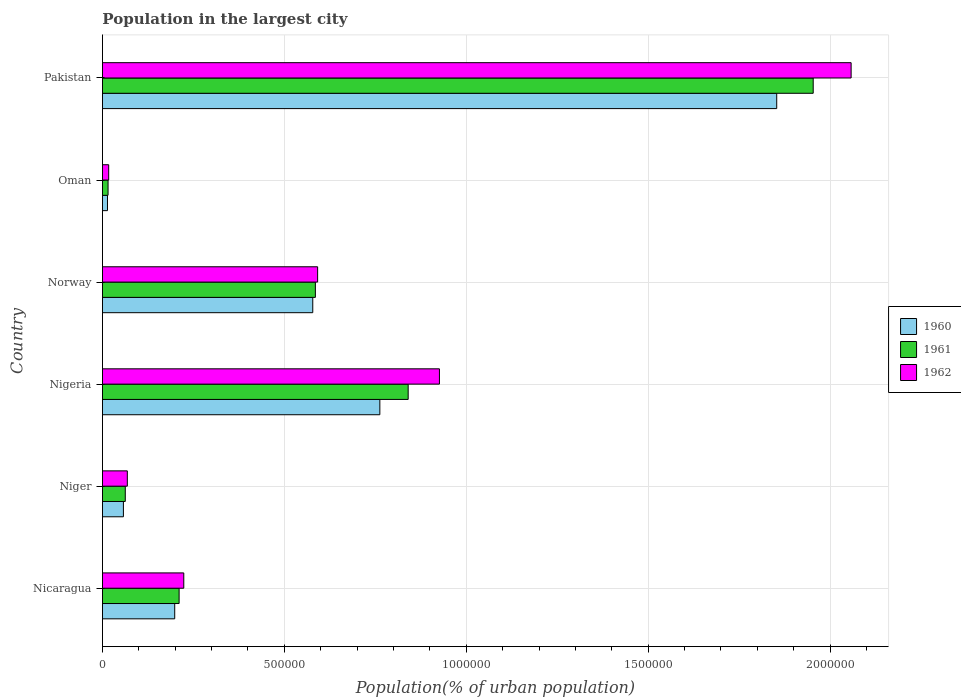How many different coloured bars are there?
Your answer should be compact. 3. Are the number of bars on each tick of the Y-axis equal?
Offer a very short reply. Yes. How many bars are there on the 1st tick from the top?
Make the answer very short. 3. What is the label of the 6th group of bars from the top?
Provide a short and direct response. Nicaragua. In how many cases, is the number of bars for a given country not equal to the number of legend labels?
Your answer should be very brief. 0. What is the population in the largest city in 1962 in Nicaragua?
Provide a succinct answer. 2.24e+05. Across all countries, what is the maximum population in the largest city in 1960?
Your answer should be very brief. 1.85e+06. Across all countries, what is the minimum population in the largest city in 1960?
Offer a very short reply. 1.38e+04. In which country was the population in the largest city in 1962 maximum?
Make the answer very short. Pakistan. In which country was the population in the largest city in 1960 minimum?
Make the answer very short. Oman. What is the total population in the largest city in 1960 in the graph?
Your answer should be compact. 3.46e+06. What is the difference between the population in the largest city in 1962 in Nigeria and that in Oman?
Provide a short and direct response. 9.09e+05. What is the difference between the population in the largest city in 1962 in Norway and the population in the largest city in 1960 in Nigeria?
Your answer should be very brief. -1.71e+05. What is the average population in the largest city in 1960 per country?
Give a very brief answer. 5.77e+05. What is the difference between the population in the largest city in 1960 and population in the largest city in 1962 in Oman?
Give a very brief answer. -3326. What is the ratio of the population in the largest city in 1961 in Niger to that in Pakistan?
Give a very brief answer. 0.03. What is the difference between the highest and the second highest population in the largest city in 1960?
Make the answer very short. 1.09e+06. What is the difference between the highest and the lowest population in the largest city in 1960?
Give a very brief answer. 1.84e+06. What does the 1st bar from the top in Oman represents?
Provide a short and direct response. 1962. How many bars are there?
Offer a terse response. 18. Are all the bars in the graph horizontal?
Provide a short and direct response. Yes. How many countries are there in the graph?
Offer a very short reply. 6. What is the difference between two consecutive major ticks on the X-axis?
Offer a very short reply. 5.00e+05. Does the graph contain any zero values?
Offer a terse response. No. Where does the legend appear in the graph?
Ensure brevity in your answer.  Center right. How many legend labels are there?
Provide a succinct answer. 3. How are the legend labels stacked?
Offer a very short reply. Vertical. What is the title of the graph?
Your answer should be compact. Population in the largest city. Does "1994" appear as one of the legend labels in the graph?
Provide a succinct answer. No. What is the label or title of the X-axis?
Give a very brief answer. Population(% of urban population). What is the Population(% of urban population) in 1960 in Nicaragua?
Your response must be concise. 1.99e+05. What is the Population(% of urban population) in 1961 in Nicaragua?
Keep it short and to the point. 2.11e+05. What is the Population(% of urban population) of 1962 in Nicaragua?
Your response must be concise. 2.24e+05. What is the Population(% of urban population) of 1960 in Niger?
Your answer should be compact. 5.75e+04. What is the Population(% of urban population) of 1961 in Niger?
Your response must be concise. 6.27e+04. What is the Population(% of urban population) in 1962 in Niger?
Offer a very short reply. 6.83e+04. What is the Population(% of urban population) of 1960 in Nigeria?
Keep it short and to the point. 7.62e+05. What is the Population(% of urban population) of 1961 in Nigeria?
Offer a very short reply. 8.40e+05. What is the Population(% of urban population) of 1962 in Nigeria?
Provide a succinct answer. 9.26e+05. What is the Population(% of urban population) in 1960 in Norway?
Provide a short and direct response. 5.78e+05. What is the Population(% of urban population) in 1961 in Norway?
Provide a short and direct response. 5.85e+05. What is the Population(% of urban population) of 1962 in Norway?
Make the answer very short. 5.91e+05. What is the Population(% of urban population) of 1960 in Oman?
Ensure brevity in your answer.  1.38e+04. What is the Population(% of urban population) in 1961 in Oman?
Provide a succinct answer. 1.54e+04. What is the Population(% of urban population) of 1962 in Oman?
Give a very brief answer. 1.71e+04. What is the Population(% of urban population) in 1960 in Pakistan?
Make the answer very short. 1.85e+06. What is the Population(% of urban population) of 1961 in Pakistan?
Offer a very short reply. 1.95e+06. What is the Population(% of urban population) in 1962 in Pakistan?
Keep it short and to the point. 2.06e+06. Across all countries, what is the maximum Population(% of urban population) of 1960?
Offer a very short reply. 1.85e+06. Across all countries, what is the maximum Population(% of urban population) of 1961?
Offer a very short reply. 1.95e+06. Across all countries, what is the maximum Population(% of urban population) of 1962?
Offer a very short reply. 2.06e+06. Across all countries, what is the minimum Population(% of urban population) in 1960?
Your answer should be compact. 1.38e+04. Across all countries, what is the minimum Population(% of urban population) of 1961?
Ensure brevity in your answer.  1.54e+04. Across all countries, what is the minimum Population(% of urban population) of 1962?
Provide a succinct answer. 1.71e+04. What is the total Population(% of urban population) in 1960 in the graph?
Offer a terse response. 3.46e+06. What is the total Population(% of urban population) of 1961 in the graph?
Your response must be concise. 3.67e+06. What is the total Population(% of urban population) of 1962 in the graph?
Make the answer very short. 3.88e+06. What is the difference between the Population(% of urban population) of 1960 in Nicaragua and that in Niger?
Ensure brevity in your answer.  1.41e+05. What is the difference between the Population(% of urban population) of 1961 in Nicaragua and that in Niger?
Keep it short and to the point. 1.48e+05. What is the difference between the Population(% of urban population) in 1962 in Nicaragua and that in Niger?
Keep it short and to the point. 1.55e+05. What is the difference between the Population(% of urban population) of 1960 in Nicaragua and that in Nigeria?
Make the answer very short. -5.64e+05. What is the difference between the Population(% of urban population) in 1961 in Nicaragua and that in Nigeria?
Give a very brief answer. -6.30e+05. What is the difference between the Population(% of urban population) in 1962 in Nicaragua and that in Nigeria?
Provide a succinct answer. -7.03e+05. What is the difference between the Population(% of urban population) in 1960 in Nicaragua and that in Norway?
Keep it short and to the point. -3.79e+05. What is the difference between the Population(% of urban population) in 1961 in Nicaragua and that in Norway?
Provide a succinct answer. -3.75e+05. What is the difference between the Population(% of urban population) of 1962 in Nicaragua and that in Norway?
Ensure brevity in your answer.  -3.68e+05. What is the difference between the Population(% of urban population) in 1960 in Nicaragua and that in Oman?
Make the answer very short. 1.85e+05. What is the difference between the Population(% of urban population) of 1961 in Nicaragua and that in Oman?
Offer a very short reply. 1.95e+05. What is the difference between the Population(% of urban population) of 1962 in Nicaragua and that in Oman?
Ensure brevity in your answer.  2.06e+05. What is the difference between the Population(% of urban population) of 1960 in Nicaragua and that in Pakistan?
Offer a very short reply. -1.65e+06. What is the difference between the Population(% of urban population) in 1961 in Nicaragua and that in Pakistan?
Ensure brevity in your answer.  -1.74e+06. What is the difference between the Population(% of urban population) in 1962 in Nicaragua and that in Pakistan?
Ensure brevity in your answer.  -1.83e+06. What is the difference between the Population(% of urban population) in 1960 in Niger and that in Nigeria?
Ensure brevity in your answer.  -7.05e+05. What is the difference between the Population(% of urban population) in 1961 in Niger and that in Nigeria?
Your response must be concise. -7.78e+05. What is the difference between the Population(% of urban population) of 1962 in Niger and that in Nigeria?
Ensure brevity in your answer.  -8.58e+05. What is the difference between the Population(% of urban population) in 1960 in Niger and that in Norway?
Give a very brief answer. -5.20e+05. What is the difference between the Population(% of urban population) in 1961 in Niger and that in Norway?
Keep it short and to the point. -5.23e+05. What is the difference between the Population(% of urban population) in 1962 in Niger and that in Norway?
Your response must be concise. -5.23e+05. What is the difference between the Population(% of urban population) in 1960 in Niger and that in Oman?
Your response must be concise. 4.38e+04. What is the difference between the Population(% of urban population) of 1961 in Niger and that in Oman?
Give a very brief answer. 4.73e+04. What is the difference between the Population(% of urban population) in 1962 in Niger and that in Oman?
Make the answer very short. 5.12e+04. What is the difference between the Population(% of urban population) of 1960 in Niger and that in Pakistan?
Ensure brevity in your answer.  -1.80e+06. What is the difference between the Population(% of urban population) in 1961 in Niger and that in Pakistan?
Give a very brief answer. -1.89e+06. What is the difference between the Population(% of urban population) in 1962 in Niger and that in Pakistan?
Offer a terse response. -1.99e+06. What is the difference between the Population(% of urban population) of 1960 in Nigeria and that in Norway?
Provide a succinct answer. 1.84e+05. What is the difference between the Population(% of urban population) of 1961 in Nigeria and that in Norway?
Provide a short and direct response. 2.55e+05. What is the difference between the Population(% of urban population) of 1962 in Nigeria and that in Norway?
Keep it short and to the point. 3.35e+05. What is the difference between the Population(% of urban population) in 1960 in Nigeria and that in Oman?
Your answer should be very brief. 7.49e+05. What is the difference between the Population(% of urban population) of 1961 in Nigeria and that in Oman?
Your response must be concise. 8.25e+05. What is the difference between the Population(% of urban population) of 1962 in Nigeria and that in Oman?
Your answer should be very brief. 9.09e+05. What is the difference between the Population(% of urban population) in 1960 in Nigeria and that in Pakistan?
Keep it short and to the point. -1.09e+06. What is the difference between the Population(% of urban population) of 1961 in Nigeria and that in Pakistan?
Ensure brevity in your answer.  -1.11e+06. What is the difference between the Population(% of urban population) of 1962 in Nigeria and that in Pakistan?
Ensure brevity in your answer.  -1.13e+06. What is the difference between the Population(% of urban population) in 1960 in Norway and that in Oman?
Keep it short and to the point. 5.64e+05. What is the difference between the Population(% of urban population) in 1961 in Norway and that in Oman?
Provide a succinct answer. 5.70e+05. What is the difference between the Population(% of urban population) of 1962 in Norway and that in Oman?
Provide a succinct answer. 5.74e+05. What is the difference between the Population(% of urban population) of 1960 in Norway and that in Pakistan?
Ensure brevity in your answer.  -1.28e+06. What is the difference between the Population(% of urban population) of 1961 in Norway and that in Pakistan?
Ensure brevity in your answer.  -1.37e+06. What is the difference between the Population(% of urban population) of 1962 in Norway and that in Pakistan?
Offer a terse response. -1.47e+06. What is the difference between the Population(% of urban population) of 1960 in Oman and that in Pakistan?
Offer a very short reply. -1.84e+06. What is the difference between the Population(% of urban population) of 1961 in Oman and that in Pakistan?
Provide a short and direct response. -1.94e+06. What is the difference between the Population(% of urban population) in 1962 in Oman and that in Pakistan?
Provide a short and direct response. -2.04e+06. What is the difference between the Population(% of urban population) in 1960 in Nicaragua and the Population(% of urban population) in 1961 in Niger?
Keep it short and to the point. 1.36e+05. What is the difference between the Population(% of urban population) in 1960 in Nicaragua and the Population(% of urban population) in 1962 in Niger?
Ensure brevity in your answer.  1.30e+05. What is the difference between the Population(% of urban population) of 1961 in Nicaragua and the Population(% of urban population) of 1962 in Niger?
Offer a very short reply. 1.42e+05. What is the difference between the Population(% of urban population) in 1960 in Nicaragua and the Population(% of urban population) in 1961 in Nigeria?
Keep it short and to the point. -6.42e+05. What is the difference between the Population(% of urban population) of 1960 in Nicaragua and the Population(% of urban population) of 1962 in Nigeria?
Your answer should be very brief. -7.28e+05. What is the difference between the Population(% of urban population) of 1961 in Nicaragua and the Population(% of urban population) of 1962 in Nigeria?
Provide a short and direct response. -7.16e+05. What is the difference between the Population(% of urban population) in 1960 in Nicaragua and the Population(% of urban population) in 1961 in Norway?
Offer a very short reply. -3.87e+05. What is the difference between the Population(% of urban population) in 1960 in Nicaragua and the Population(% of urban population) in 1962 in Norway?
Offer a terse response. -3.93e+05. What is the difference between the Population(% of urban population) in 1961 in Nicaragua and the Population(% of urban population) in 1962 in Norway?
Offer a terse response. -3.81e+05. What is the difference between the Population(% of urban population) in 1960 in Nicaragua and the Population(% of urban population) in 1961 in Oman?
Make the answer very short. 1.83e+05. What is the difference between the Population(% of urban population) of 1960 in Nicaragua and the Population(% of urban population) of 1962 in Oman?
Give a very brief answer. 1.81e+05. What is the difference between the Population(% of urban population) of 1961 in Nicaragua and the Population(% of urban population) of 1962 in Oman?
Provide a succinct answer. 1.94e+05. What is the difference between the Population(% of urban population) of 1960 in Nicaragua and the Population(% of urban population) of 1961 in Pakistan?
Offer a very short reply. -1.76e+06. What is the difference between the Population(% of urban population) of 1960 in Nicaragua and the Population(% of urban population) of 1962 in Pakistan?
Make the answer very short. -1.86e+06. What is the difference between the Population(% of urban population) of 1961 in Nicaragua and the Population(% of urban population) of 1962 in Pakistan?
Make the answer very short. -1.85e+06. What is the difference between the Population(% of urban population) in 1960 in Niger and the Population(% of urban population) in 1961 in Nigeria?
Keep it short and to the point. -7.83e+05. What is the difference between the Population(% of urban population) of 1960 in Niger and the Population(% of urban population) of 1962 in Nigeria?
Give a very brief answer. -8.69e+05. What is the difference between the Population(% of urban population) in 1961 in Niger and the Population(% of urban population) in 1962 in Nigeria?
Offer a very short reply. -8.64e+05. What is the difference between the Population(% of urban population) of 1960 in Niger and the Population(% of urban population) of 1961 in Norway?
Offer a very short reply. -5.28e+05. What is the difference between the Population(% of urban population) in 1960 in Niger and the Population(% of urban population) in 1962 in Norway?
Provide a short and direct response. -5.34e+05. What is the difference between the Population(% of urban population) in 1961 in Niger and the Population(% of urban population) in 1962 in Norway?
Keep it short and to the point. -5.29e+05. What is the difference between the Population(% of urban population) in 1960 in Niger and the Population(% of urban population) in 1961 in Oman?
Give a very brief answer. 4.22e+04. What is the difference between the Population(% of urban population) in 1960 in Niger and the Population(% of urban population) in 1962 in Oman?
Provide a succinct answer. 4.04e+04. What is the difference between the Population(% of urban population) in 1961 in Niger and the Population(% of urban population) in 1962 in Oman?
Offer a terse response. 4.56e+04. What is the difference between the Population(% of urban population) of 1960 in Niger and the Population(% of urban population) of 1961 in Pakistan?
Make the answer very short. -1.90e+06. What is the difference between the Population(% of urban population) in 1960 in Niger and the Population(% of urban population) in 1962 in Pakistan?
Keep it short and to the point. -2.00e+06. What is the difference between the Population(% of urban population) of 1961 in Niger and the Population(% of urban population) of 1962 in Pakistan?
Provide a short and direct response. -2.00e+06. What is the difference between the Population(% of urban population) in 1960 in Nigeria and the Population(% of urban population) in 1961 in Norway?
Give a very brief answer. 1.77e+05. What is the difference between the Population(% of urban population) of 1960 in Nigeria and the Population(% of urban population) of 1962 in Norway?
Your response must be concise. 1.71e+05. What is the difference between the Population(% of urban population) of 1961 in Nigeria and the Population(% of urban population) of 1962 in Norway?
Your response must be concise. 2.49e+05. What is the difference between the Population(% of urban population) of 1960 in Nigeria and the Population(% of urban population) of 1961 in Oman?
Your response must be concise. 7.47e+05. What is the difference between the Population(% of urban population) in 1960 in Nigeria and the Population(% of urban population) in 1962 in Oman?
Ensure brevity in your answer.  7.45e+05. What is the difference between the Population(% of urban population) of 1961 in Nigeria and the Population(% of urban population) of 1962 in Oman?
Offer a very short reply. 8.23e+05. What is the difference between the Population(% of urban population) of 1960 in Nigeria and the Population(% of urban population) of 1961 in Pakistan?
Offer a terse response. -1.19e+06. What is the difference between the Population(% of urban population) of 1960 in Nigeria and the Population(% of urban population) of 1962 in Pakistan?
Provide a short and direct response. -1.30e+06. What is the difference between the Population(% of urban population) in 1961 in Nigeria and the Population(% of urban population) in 1962 in Pakistan?
Keep it short and to the point. -1.22e+06. What is the difference between the Population(% of urban population) of 1960 in Norway and the Population(% of urban population) of 1961 in Oman?
Ensure brevity in your answer.  5.63e+05. What is the difference between the Population(% of urban population) in 1960 in Norway and the Population(% of urban population) in 1962 in Oman?
Offer a very short reply. 5.61e+05. What is the difference between the Population(% of urban population) of 1961 in Norway and the Population(% of urban population) of 1962 in Oman?
Offer a terse response. 5.68e+05. What is the difference between the Population(% of urban population) of 1960 in Norway and the Population(% of urban population) of 1961 in Pakistan?
Your answer should be compact. -1.38e+06. What is the difference between the Population(% of urban population) in 1960 in Norway and the Population(% of urban population) in 1962 in Pakistan?
Provide a short and direct response. -1.48e+06. What is the difference between the Population(% of urban population) in 1961 in Norway and the Population(% of urban population) in 1962 in Pakistan?
Your answer should be compact. -1.47e+06. What is the difference between the Population(% of urban population) of 1960 in Oman and the Population(% of urban population) of 1961 in Pakistan?
Give a very brief answer. -1.94e+06. What is the difference between the Population(% of urban population) of 1960 in Oman and the Population(% of urban population) of 1962 in Pakistan?
Your response must be concise. -2.04e+06. What is the difference between the Population(% of urban population) of 1961 in Oman and the Population(% of urban population) of 1962 in Pakistan?
Make the answer very short. -2.04e+06. What is the average Population(% of urban population) of 1960 per country?
Provide a short and direct response. 5.77e+05. What is the average Population(% of urban population) in 1961 per country?
Offer a very short reply. 6.11e+05. What is the average Population(% of urban population) of 1962 per country?
Your answer should be compact. 6.47e+05. What is the difference between the Population(% of urban population) in 1960 and Population(% of urban population) in 1961 in Nicaragua?
Your answer should be very brief. -1.21e+04. What is the difference between the Population(% of urban population) in 1960 and Population(% of urban population) in 1962 in Nicaragua?
Your response must be concise. -2.49e+04. What is the difference between the Population(% of urban population) of 1961 and Population(% of urban population) of 1962 in Nicaragua?
Your answer should be compact. -1.28e+04. What is the difference between the Population(% of urban population) in 1960 and Population(% of urban population) in 1961 in Niger?
Provide a succinct answer. -5156. What is the difference between the Population(% of urban population) in 1960 and Population(% of urban population) in 1962 in Niger?
Keep it short and to the point. -1.08e+04. What is the difference between the Population(% of urban population) in 1961 and Population(% of urban population) in 1962 in Niger?
Offer a very short reply. -5625. What is the difference between the Population(% of urban population) of 1960 and Population(% of urban population) of 1961 in Nigeria?
Your answer should be compact. -7.79e+04. What is the difference between the Population(% of urban population) of 1960 and Population(% of urban population) of 1962 in Nigeria?
Provide a succinct answer. -1.64e+05. What is the difference between the Population(% of urban population) of 1961 and Population(% of urban population) of 1962 in Nigeria?
Ensure brevity in your answer.  -8.59e+04. What is the difference between the Population(% of urban population) in 1960 and Population(% of urban population) in 1961 in Norway?
Offer a very short reply. -7186. What is the difference between the Population(% of urban population) of 1960 and Population(% of urban population) of 1962 in Norway?
Offer a terse response. -1.34e+04. What is the difference between the Population(% of urban population) in 1961 and Population(% of urban population) in 1962 in Norway?
Make the answer very short. -6168. What is the difference between the Population(% of urban population) in 1960 and Population(% of urban population) in 1961 in Oman?
Give a very brief answer. -1572. What is the difference between the Population(% of urban population) in 1960 and Population(% of urban population) in 1962 in Oman?
Your response must be concise. -3326. What is the difference between the Population(% of urban population) in 1961 and Population(% of urban population) in 1962 in Oman?
Provide a succinct answer. -1754. What is the difference between the Population(% of urban population) of 1960 and Population(% of urban population) of 1961 in Pakistan?
Ensure brevity in your answer.  -1.00e+05. What is the difference between the Population(% of urban population) in 1960 and Population(% of urban population) in 1962 in Pakistan?
Keep it short and to the point. -2.05e+05. What is the difference between the Population(% of urban population) in 1961 and Population(% of urban population) in 1962 in Pakistan?
Provide a short and direct response. -1.04e+05. What is the ratio of the Population(% of urban population) in 1960 in Nicaragua to that in Niger?
Keep it short and to the point. 3.45. What is the ratio of the Population(% of urban population) in 1961 in Nicaragua to that in Niger?
Your answer should be compact. 3.36. What is the ratio of the Population(% of urban population) of 1962 in Nicaragua to that in Niger?
Ensure brevity in your answer.  3.27. What is the ratio of the Population(% of urban population) in 1960 in Nicaragua to that in Nigeria?
Provide a succinct answer. 0.26. What is the ratio of the Population(% of urban population) in 1961 in Nicaragua to that in Nigeria?
Your answer should be very brief. 0.25. What is the ratio of the Population(% of urban population) in 1962 in Nicaragua to that in Nigeria?
Your answer should be very brief. 0.24. What is the ratio of the Population(% of urban population) of 1960 in Nicaragua to that in Norway?
Give a very brief answer. 0.34. What is the ratio of the Population(% of urban population) of 1961 in Nicaragua to that in Norway?
Your answer should be very brief. 0.36. What is the ratio of the Population(% of urban population) of 1962 in Nicaragua to that in Norway?
Offer a terse response. 0.38. What is the ratio of the Population(% of urban population) of 1960 in Nicaragua to that in Oman?
Give a very brief answer. 14.4. What is the ratio of the Population(% of urban population) of 1961 in Nicaragua to that in Oman?
Your answer should be very brief. 13.71. What is the ratio of the Population(% of urban population) of 1962 in Nicaragua to that in Oman?
Your answer should be compact. 13.06. What is the ratio of the Population(% of urban population) of 1960 in Nicaragua to that in Pakistan?
Your response must be concise. 0.11. What is the ratio of the Population(% of urban population) of 1961 in Nicaragua to that in Pakistan?
Your response must be concise. 0.11. What is the ratio of the Population(% of urban population) in 1962 in Nicaragua to that in Pakistan?
Offer a very short reply. 0.11. What is the ratio of the Population(% of urban population) in 1960 in Niger to that in Nigeria?
Provide a succinct answer. 0.08. What is the ratio of the Population(% of urban population) in 1961 in Niger to that in Nigeria?
Your answer should be compact. 0.07. What is the ratio of the Population(% of urban population) of 1962 in Niger to that in Nigeria?
Your response must be concise. 0.07. What is the ratio of the Population(% of urban population) in 1960 in Niger to that in Norway?
Make the answer very short. 0.1. What is the ratio of the Population(% of urban population) of 1961 in Niger to that in Norway?
Ensure brevity in your answer.  0.11. What is the ratio of the Population(% of urban population) of 1962 in Niger to that in Norway?
Your answer should be very brief. 0.12. What is the ratio of the Population(% of urban population) in 1960 in Niger to that in Oman?
Offer a terse response. 4.17. What is the ratio of the Population(% of urban population) of 1961 in Niger to that in Oman?
Your answer should be compact. 4.08. What is the ratio of the Population(% of urban population) of 1962 in Niger to that in Oman?
Offer a very short reply. 3.99. What is the ratio of the Population(% of urban population) of 1960 in Niger to that in Pakistan?
Offer a terse response. 0.03. What is the ratio of the Population(% of urban population) of 1961 in Niger to that in Pakistan?
Ensure brevity in your answer.  0.03. What is the ratio of the Population(% of urban population) of 1962 in Niger to that in Pakistan?
Offer a very short reply. 0.03. What is the ratio of the Population(% of urban population) in 1960 in Nigeria to that in Norway?
Offer a terse response. 1.32. What is the ratio of the Population(% of urban population) in 1961 in Nigeria to that in Norway?
Provide a succinct answer. 1.44. What is the ratio of the Population(% of urban population) in 1962 in Nigeria to that in Norway?
Make the answer very short. 1.57. What is the ratio of the Population(% of urban population) of 1960 in Nigeria to that in Oman?
Your answer should be very brief. 55.28. What is the ratio of the Population(% of urban population) of 1961 in Nigeria to that in Oman?
Give a very brief answer. 54.69. What is the ratio of the Population(% of urban population) in 1962 in Nigeria to that in Oman?
Ensure brevity in your answer.  54.11. What is the ratio of the Population(% of urban population) of 1960 in Nigeria to that in Pakistan?
Offer a very short reply. 0.41. What is the ratio of the Population(% of urban population) in 1961 in Nigeria to that in Pakistan?
Keep it short and to the point. 0.43. What is the ratio of the Population(% of urban population) in 1962 in Nigeria to that in Pakistan?
Offer a terse response. 0.45. What is the ratio of the Population(% of urban population) in 1960 in Norway to that in Oman?
Give a very brief answer. 41.91. What is the ratio of the Population(% of urban population) of 1961 in Norway to that in Oman?
Offer a terse response. 38.09. What is the ratio of the Population(% of urban population) of 1962 in Norway to that in Oman?
Your answer should be very brief. 34.55. What is the ratio of the Population(% of urban population) of 1960 in Norway to that in Pakistan?
Offer a terse response. 0.31. What is the ratio of the Population(% of urban population) of 1961 in Norway to that in Pakistan?
Provide a succinct answer. 0.3. What is the ratio of the Population(% of urban population) in 1962 in Norway to that in Pakistan?
Your response must be concise. 0.29. What is the ratio of the Population(% of urban population) in 1960 in Oman to that in Pakistan?
Your answer should be very brief. 0.01. What is the ratio of the Population(% of urban population) of 1961 in Oman to that in Pakistan?
Provide a short and direct response. 0.01. What is the ratio of the Population(% of urban population) in 1962 in Oman to that in Pakistan?
Offer a very short reply. 0.01. What is the difference between the highest and the second highest Population(% of urban population) in 1960?
Offer a terse response. 1.09e+06. What is the difference between the highest and the second highest Population(% of urban population) of 1961?
Offer a very short reply. 1.11e+06. What is the difference between the highest and the second highest Population(% of urban population) in 1962?
Provide a short and direct response. 1.13e+06. What is the difference between the highest and the lowest Population(% of urban population) of 1960?
Your response must be concise. 1.84e+06. What is the difference between the highest and the lowest Population(% of urban population) of 1961?
Offer a terse response. 1.94e+06. What is the difference between the highest and the lowest Population(% of urban population) in 1962?
Keep it short and to the point. 2.04e+06. 